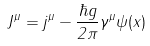Convert formula to latex. <formula><loc_0><loc_0><loc_500><loc_500>J ^ { \mu } = j ^ { \mu } - \frac { \hbar { g } } { 2 \pi } \gamma ^ { \mu } \psi ( x )</formula> 